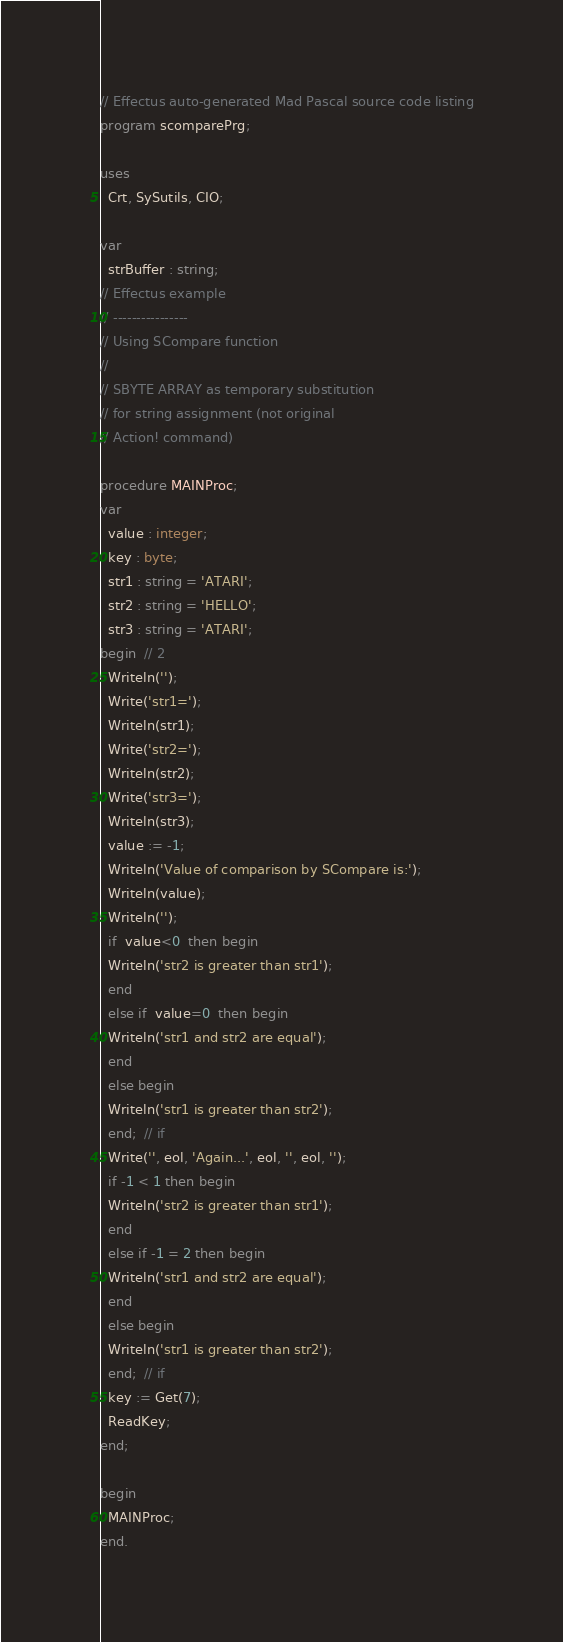Convert code to text. <code><loc_0><loc_0><loc_500><loc_500><_Pascal_>// Effectus auto-generated Mad Pascal source code listing
program scomparePrg;

uses
  Crt, SySutils, CIO;

var
  strBuffer : string;
// Effectus example
// ----------------
// Using SCompare function
// 
// SBYTE ARRAY as temporary substitution
// for string assignment (not original
// Action! command)

procedure MAINProc;
var
  value : integer;
  key : byte;
  str1 : string = 'ATARI';
  str2 : string = 'HELLO';
  str3 : string = 'ATARI';
begin  // 2
  Writeln('');
  Write('str1=');
  Writeln(str1);
  Write('str2=');
  Writeln(str2);
  Write('str3=');
  Writeln(str3);
  value := -1;
  Writeln('Value of comparison by SCompare is:');
  Writeln(value);
  Writeln('');
  if  value<0  then begin
  Writeln('str2 is greater than str1');
  end
  else if  value=0  then begin
  Writeln('str1 and str2 are equal');
  end
  else begin
  Writeln('str1 is greater than str2');
  end;  // if
  Write('', eol, 'Again...', eol, '', eol, '');
  if -1 < 1 then begin
  Writeln('str2 is greater than str1');
  end
  else if -1 = 2 then begin
  Writeln('str1 and str2 are equal');
  end
  else begin
  Writeln('str1 is greater than str2');
  end;  // if
  key := Get(7);
  ReadKey;
end;

begin
  MAINProc;
end.
</code> 